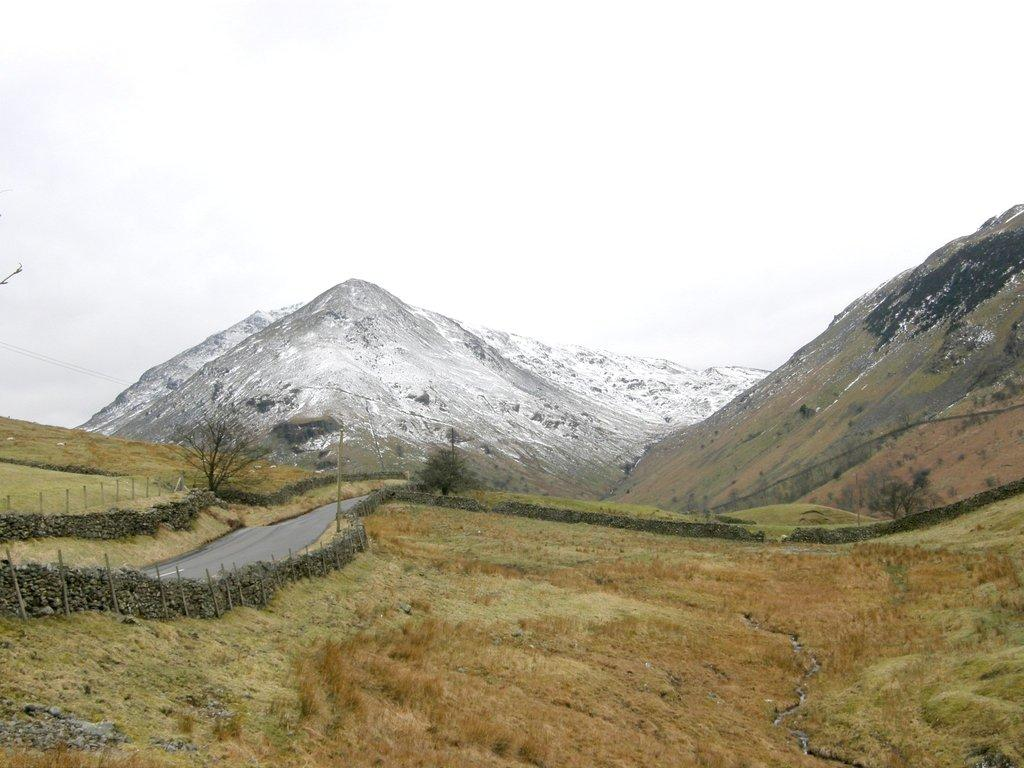What type of landscape is depicted in the image? The image features grasslands. Are there any structures or features in the grasslands? Yes, there is a stone fence in the image. What else can be seen in the image besides the grasslands and stone fence? There is a road, trees, mountains, and the sky visible in the image. How would you describe the sky in the image? The sky appears to be plain or clear in the background of the image. What type of copper object can be seen in the image? There is no copper object present in the image. How many roses are visible in the image? There are no roses depicted in the image. 